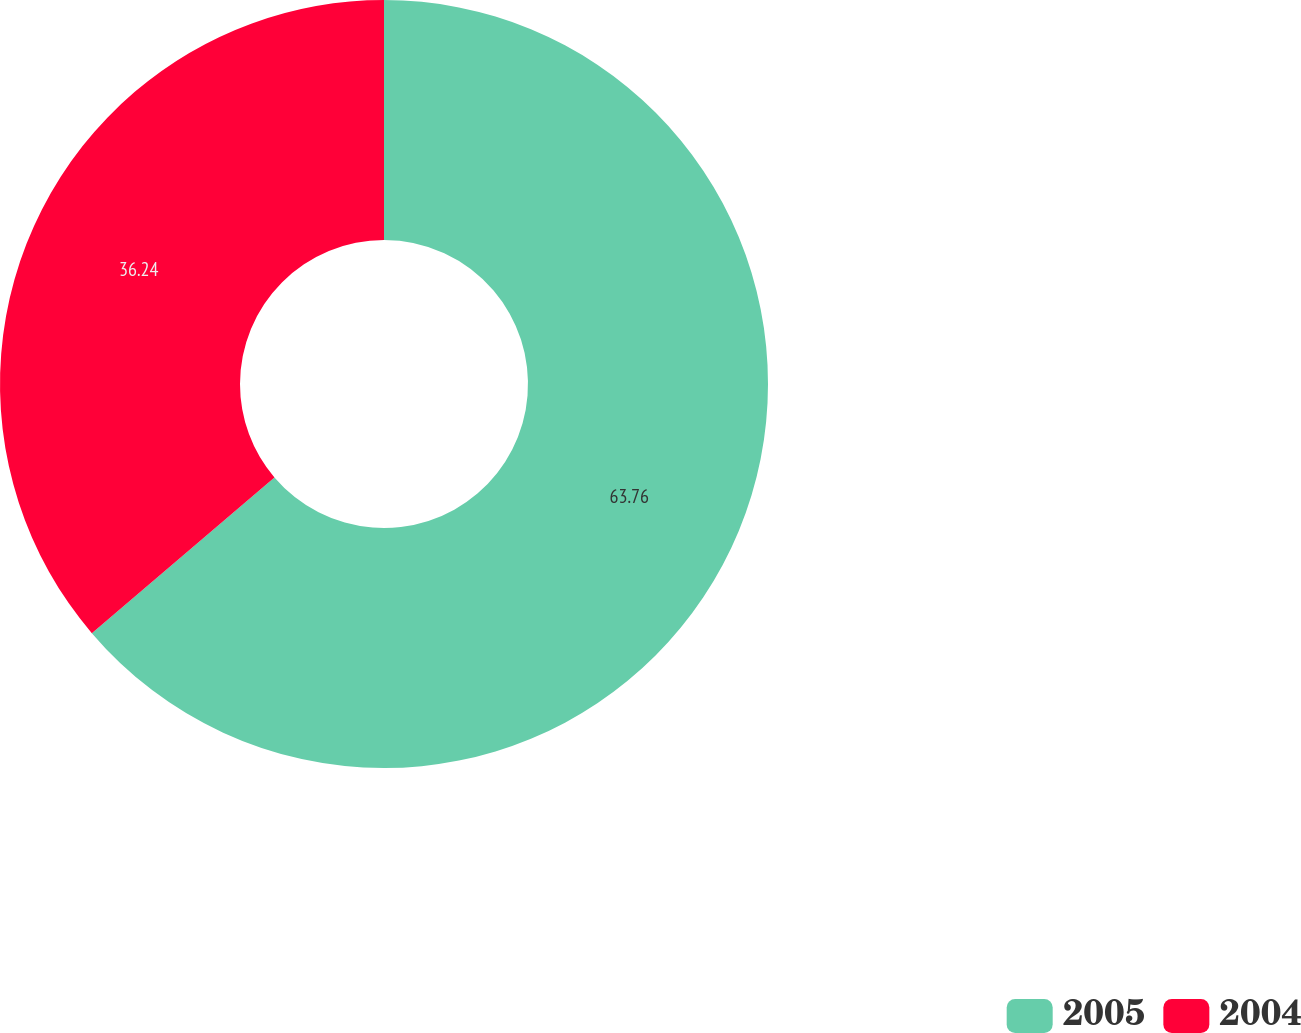Convert chart. <chart><loc_0><loc_0><loc_500><loc_500><pie_chart><fcel>2005<fcel>2004<nl><fcel>63.76%<fcel>36.24%<nl></chart> 